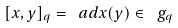<formula> <loc_0><loc_0><loc_500><loc_500>[ x , y ] _ { q } = \ a d x ( y ) \in \ g _ { q }</formula> 